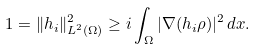Convert formula to latex. <formula><loc_0><loc_0><loc_500><loc_500>1 = \| h _ { i } \| _ { L ^ { 2 } ( \Omega ) } ^ { 2 } \geq i \int _ { \Omega } | \nabla ( h _ { i } \rho ) | ^ { 2 } \, d x .</formula> 